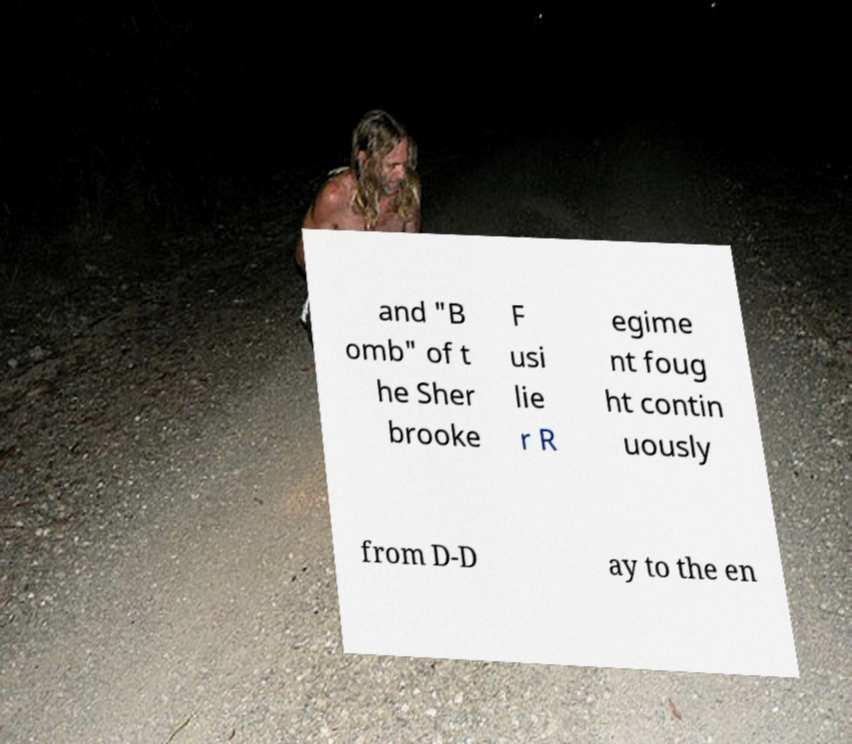What messages or text are displayed in this image? I need them in a readable, typed format. and "B omb" of t he Sher brooke F usi lie r R egime nt foug ht contin uously from D-D ay to the en 